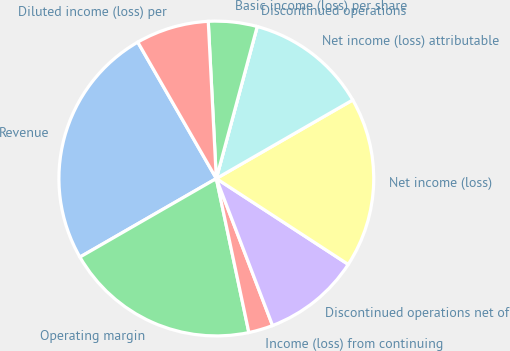Convert chart. <chart><loc_0><loc_0><loc_500><loc_500><pie_chart><fcel>Revenue<fcel>Operating margin<fcel>Income (loss) from continuing<fcel>Discontinued operations net of<fcel>Net income (loss)<fcel>Net income (loss) attributable<fcel>Discontinued operations<fcel>Basic income (loss) per share<fcel>Diluted income (loss) per<nl><fcel>25.0%<fcel>20.0%<fcel>2.5%<fcel>10.0%<fcel>17.5%<fcel>12.5%<fcel>0.0%<fcel>5.0%<fcel>7.5%<nl></chart> 